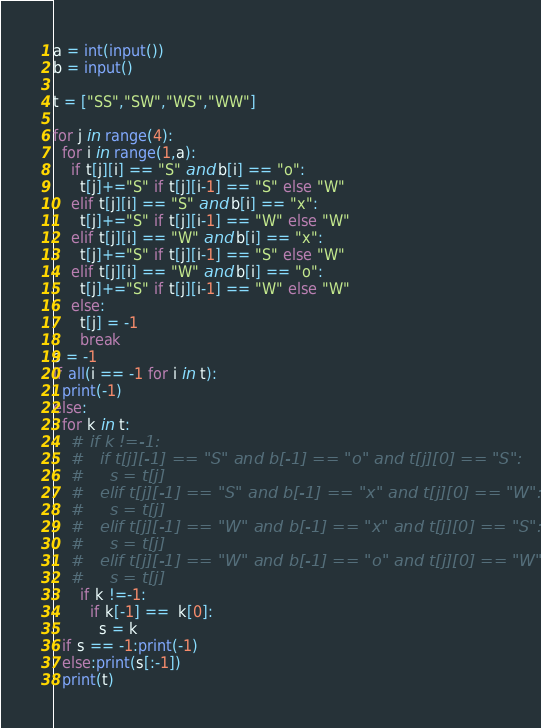<code> <loc_0><loc_0><loc_500><loc_500><_Python_>a = int(input())
b = input()

t = ["SS","SW","WS","WW"]

for j in range(4):
  for i in range(1,a):
    if t[j][i] == "S" and b[i] == "o":
      t[j]+="S" if t[j][i-1] == "S" else "W"
    elif t[j][i] == "S" and b[i] == "x":
      t[j]+="S" if t[j][i-1] == "W" else "W"
    elif t[j][i] == "W" and b[i] == "x":
      t[j]+="S" if t[j][i-1] == "S" else "W"
    elif t[j][i] == "W" and b[i] == "o":
      t[j]+="S" if t[j][i-1] == "W" else "W"
    else:
      t[j] = -1
      break
s = -1
if all(i == -1 for i in t):
  print(-1)
else:
  for k in t:
    # if k !=-1:
    #   if t[j][-1] == "S" and b[-1] == "o" and t[j][0] == "S":
    #     s = t[j]
    #   elif t[j][-1] == "S" and b[-1] == "x" and t[j][0] == "W":
    #     s = t[j]
    #   elif t[j][-1] == "W" and b[-1] == "x" and t[j][0] == "S":
    #     s = t[j]
    #   elif t[j][-1] == "W" and b[-1] == "o" and t[j][0] == "W":
    #     s = t[j]
      if k !=-1:
        if k[-1] ==  k[0]:
          s = k
  if s == -1:print(-1)
  else:print(s[:-1])
  print(t)

</code> 